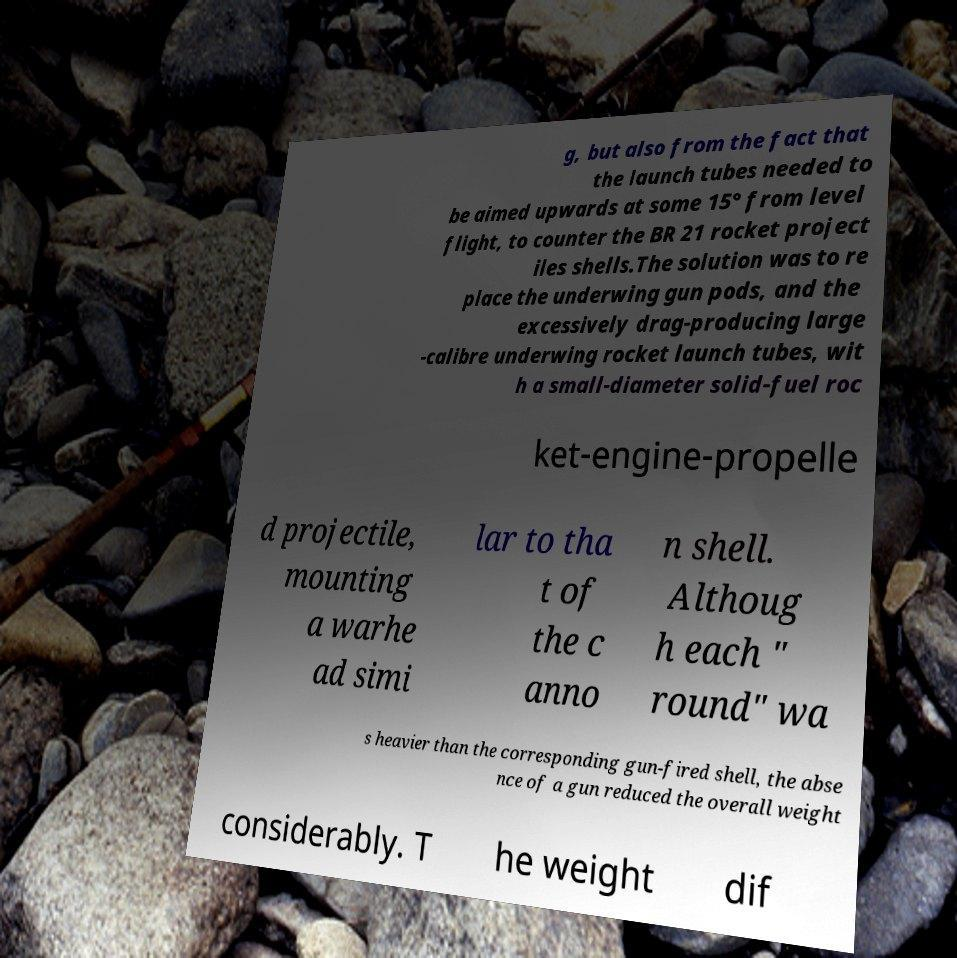There's text embedded in this image that I need extracted. Can you transcribe it verbatim? g, but also from the fact that the launch tubes needed to be aimed upwards at some 15° from level flight, to counter the BR 21 rocket project iles shells.The solution was to re place the underwing gun pods, and the excessively drag-producing large -calibre underwing rocket launch tubes, wit h a small-diameter solid-fuel roc ket-engine-propelle d projectile, mounting a warhe ad simi lar to tha t of the c anno n shell. Althoug h each " round" wa s heavier than the corresponding gun-fired shell, the abse nce of a gun reduced the overall weight considerably. T he weight dif 